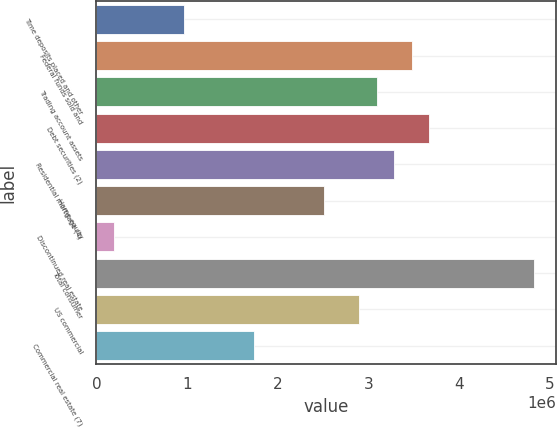Convert chart. <chart><loc_0><loc_0><loc_500><loc_500><bar_chart><fcel>Time deposits placed and other<fcel>Federal funds sold and<fcel>Trading account assets<fcel>Debt securities (2)<fcel>Residential mortgage (4)<fcel>Home equity<fcel>Discontinued real estate<fcel>Total consumer<fcel>US commercial<fcel>Commercial real estate (7)<nl><fcel>969343<fcel>3.47501e+06<fcel>3.08952e+06<fcel>3.66775e+06<fcel>3.28226e+06<fcel>2.51129e+06<fcel>198369<fcel>4.82421e+06<fcel>2.89678e+06<fcel>1.74032e+06<nl></chart> 